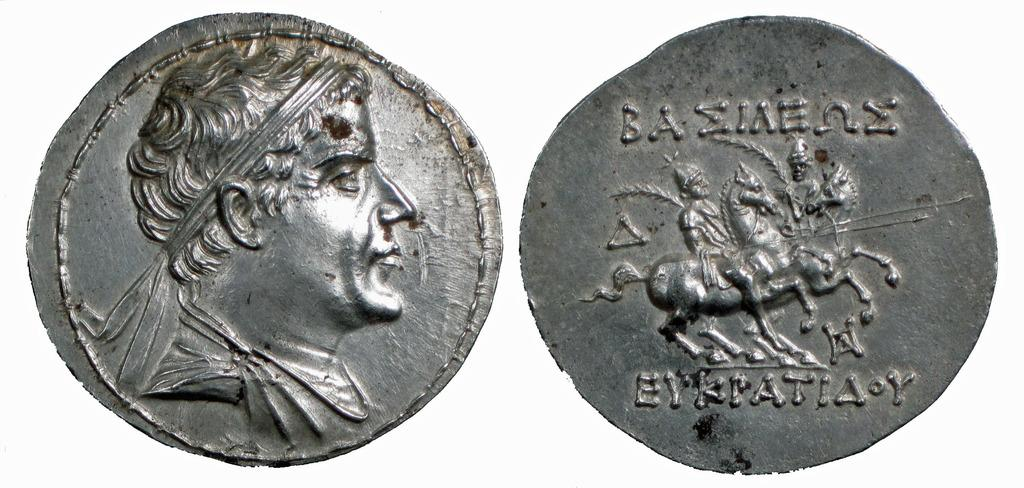<image>
Write a terse but informative summary of the picture. A Baeiaene coin showing both the head and tail side. 